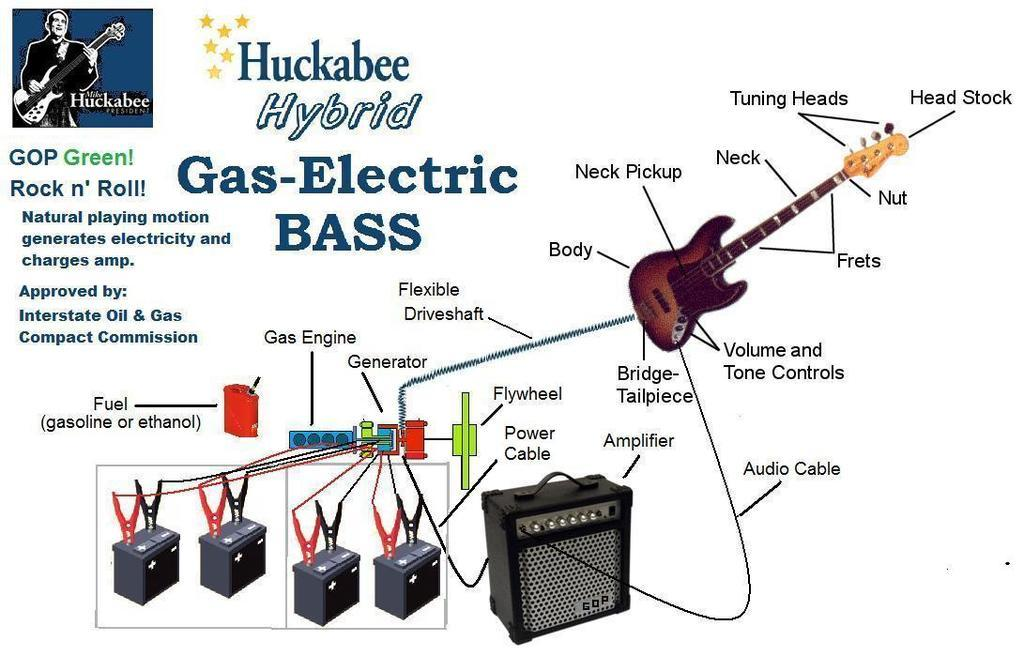What can be seen hanging on the wall in the picture? There is a poster in the picture. What else is visible in the picture besides the poster? There are musical instruments present in the picture. Is there any representation of a person in the image? Yes, there is a picture of a person in the image. What type of weather can be seen in the image? There is no weather depicted in the image; it is a picture of a poster, musical instruments, and a person. Can you tell me how many matches are visible in the image? There are no matches present in the image. 